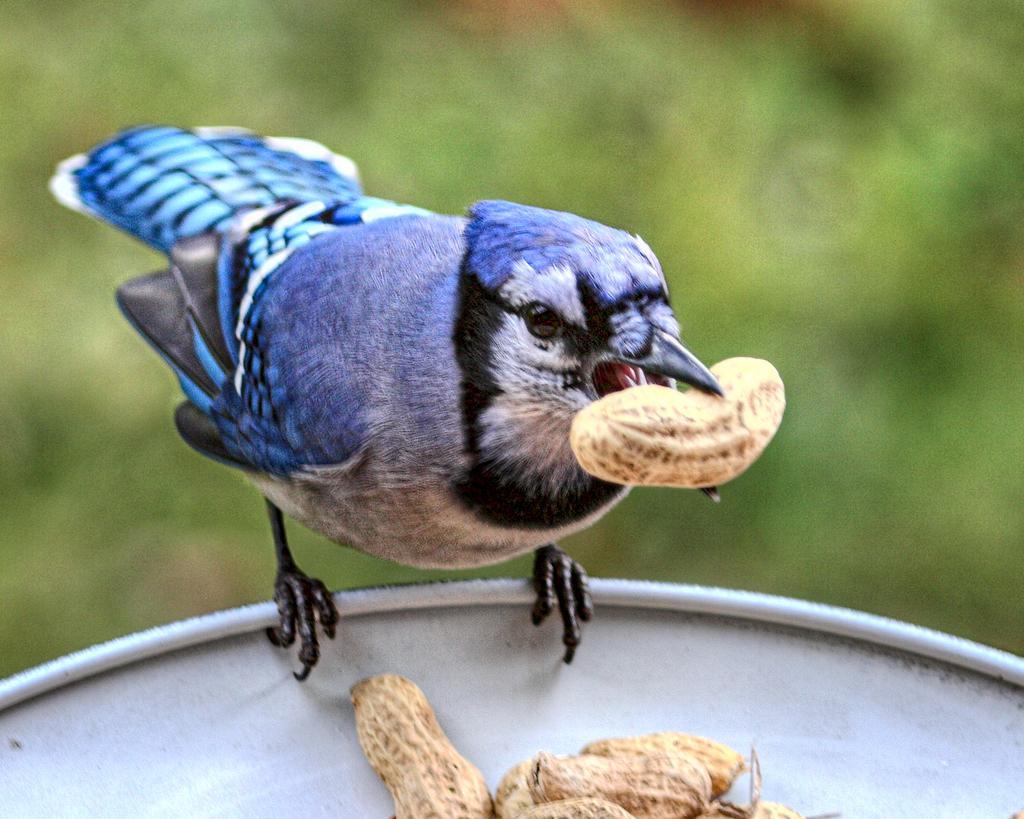Describe this image in one or two sentences. In the picture I can see a blue color bird and we can see the peanut in its mouth. Here we can see a few more peanuts are placed in the white color surface. The background of the image is blurred, which is in green color. 